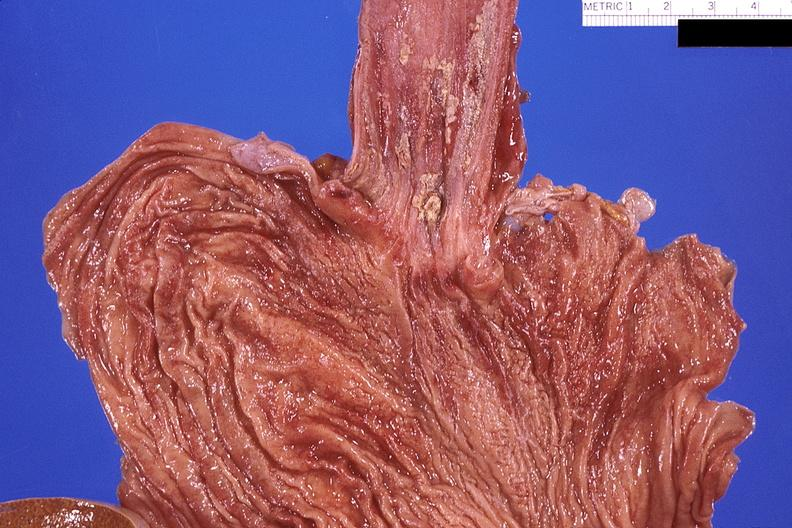does this image show esohagus, candida?
Answer the question using a single word or phrase. Yes 